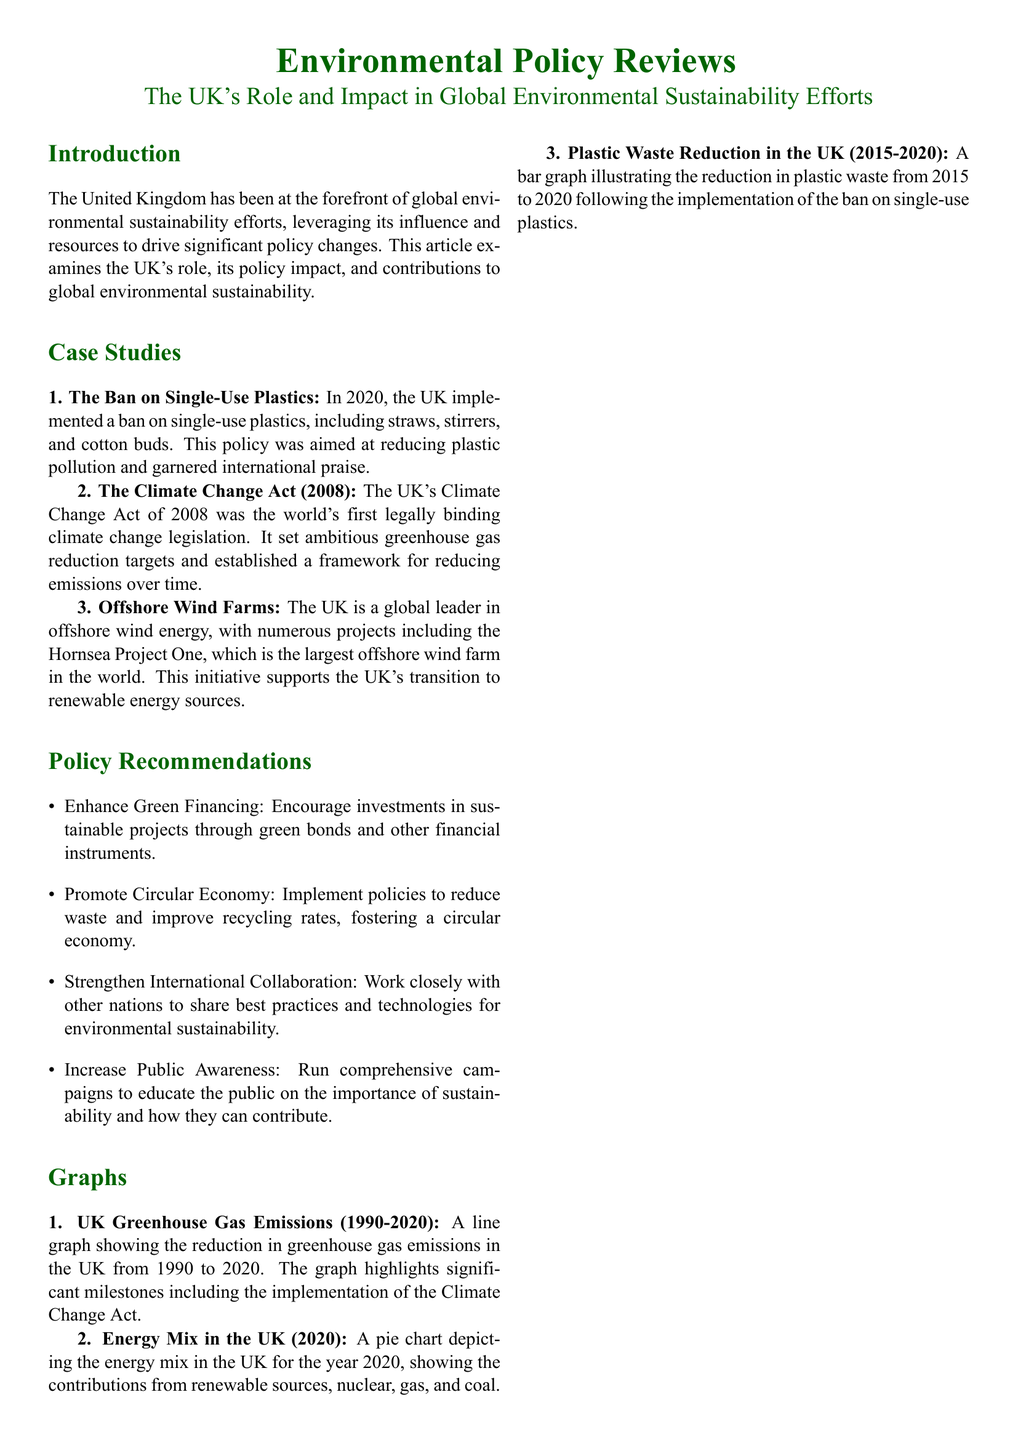What year was the ban on single-use plastics implemented? The document states that the UK implemented a ban on single-use plastics in 2020.
Answer: 2020 What is the title of the UK's first legally binding climate change legislation? The document refers to the UK's Climate Change Act as the world's first legally binding climate change legislation.
Answer: Climate Change Act Which offshore wind farm is mentioned as the largest in the world? The document mentions the Hornsea Project One as the largest offshore wind farm in the world.
Answer: Hornsea Project One What is one of the proposed policies to enhance sustainability in the UK? The document lists enhancing green financing as one of the policy recommendations to encourage investments in sustainable projects.
Answer: Enhance Green Financing What type of graph illustrates the reduction in plastic waste from 2015 to 2020? The document states that a bar graph illustrates the reduction in plastic waste following the implementation of the ban on single-use plastics.
Answer: Bar graph How much did UK greenhouse gas emissions decrease from 1990 to 2020? The document contains a line graph showing the reduction in greenhouse gas emissions from 1990 to 2020, highlighting significant milestones, but does not provide a specific number here.
Answer: Not specified What color represents the UK’s role in the document's title? The title of the document is presented with dark green text color.
Answer: Dark green What is a key feature of the Energy Mix graph described in the document? The document mentions that the Energy Mix graph depicts the contributions from various energy sources in the UK for the year 2020.
Answer: Pie chart 